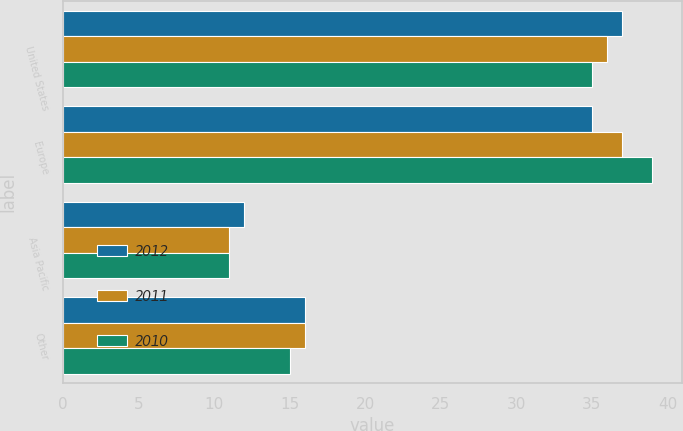Convert chart. <chart><loc_0><loc_0><loc_500><loc_500><stacked_bar_chart><ecel><fcel>United States<fcel>Europe<fcel>Asia Pacific<fcel>Other<nl><fcel>2012<fcel>37<fcel>35<fcel>12<fcel>16<nl><fcel>2011<fcel>36<fcel>37<fcel>11<fcel>16<nl><fcel>2010<fcel>35<fcel>39<fcel>11<fcel>15<nl></chart> 